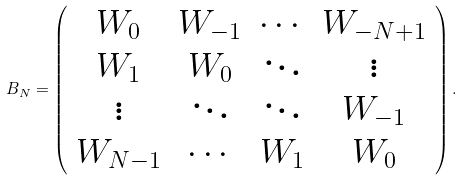<formula> <loc_0><loc_0><loc_500><loc_500>B _ { N } = \left ( \begin{array} { c c c c } W _ { 0 } & W _ { - 1 } & \cdots & W _ { - N + 1 } \\ W _ { 1 } & W _ { 0 } & \ddots & \vdots \\ \vdots & \ddots & \ddots & W _ { - 1 } \\ W _ { N - 1 } & \cdots & W _ { 1 } & W _ { 0 } \\ \end{array} \right ) .</formula> 